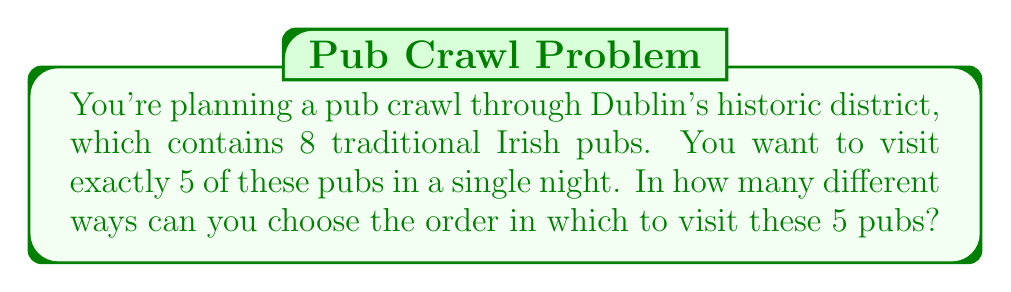Show me your answer to this math problem. Let's approach this step-by-step:

1) First, we need to choose which 5 pubs out of the 8 we will visit. This is a combination problem, as the order doesn't matter at this stage. We can calculate this using the combination formula:

   $$C(8,5) = \frac{8!}{5!(8-5)!} = \frac{8!}{5!3!} = 56$$

2) Now that we've chosen our 5 pubs, we need to determine in how many ways we can order these 5 pubs for our crawl. This is a permutation problem, as the order now matters. The number of permutations of 5 items is simply:

   $$P(5) = 5! = 5 \times 4 \times 3 \times 2 \times 1 = 120$$

3) According to the multiplication principle, if we have 56 ways to choose 5 pubs, and for each of these choices we have 120 ways to order them, the total number of possible pub crawl routes is:

   $$56 \times 120 = 6,720$$

Therefore, there are 6,720 different possible routes for your pub crawl through Dublin's historic district.
Answer: 6,720 possible routes 